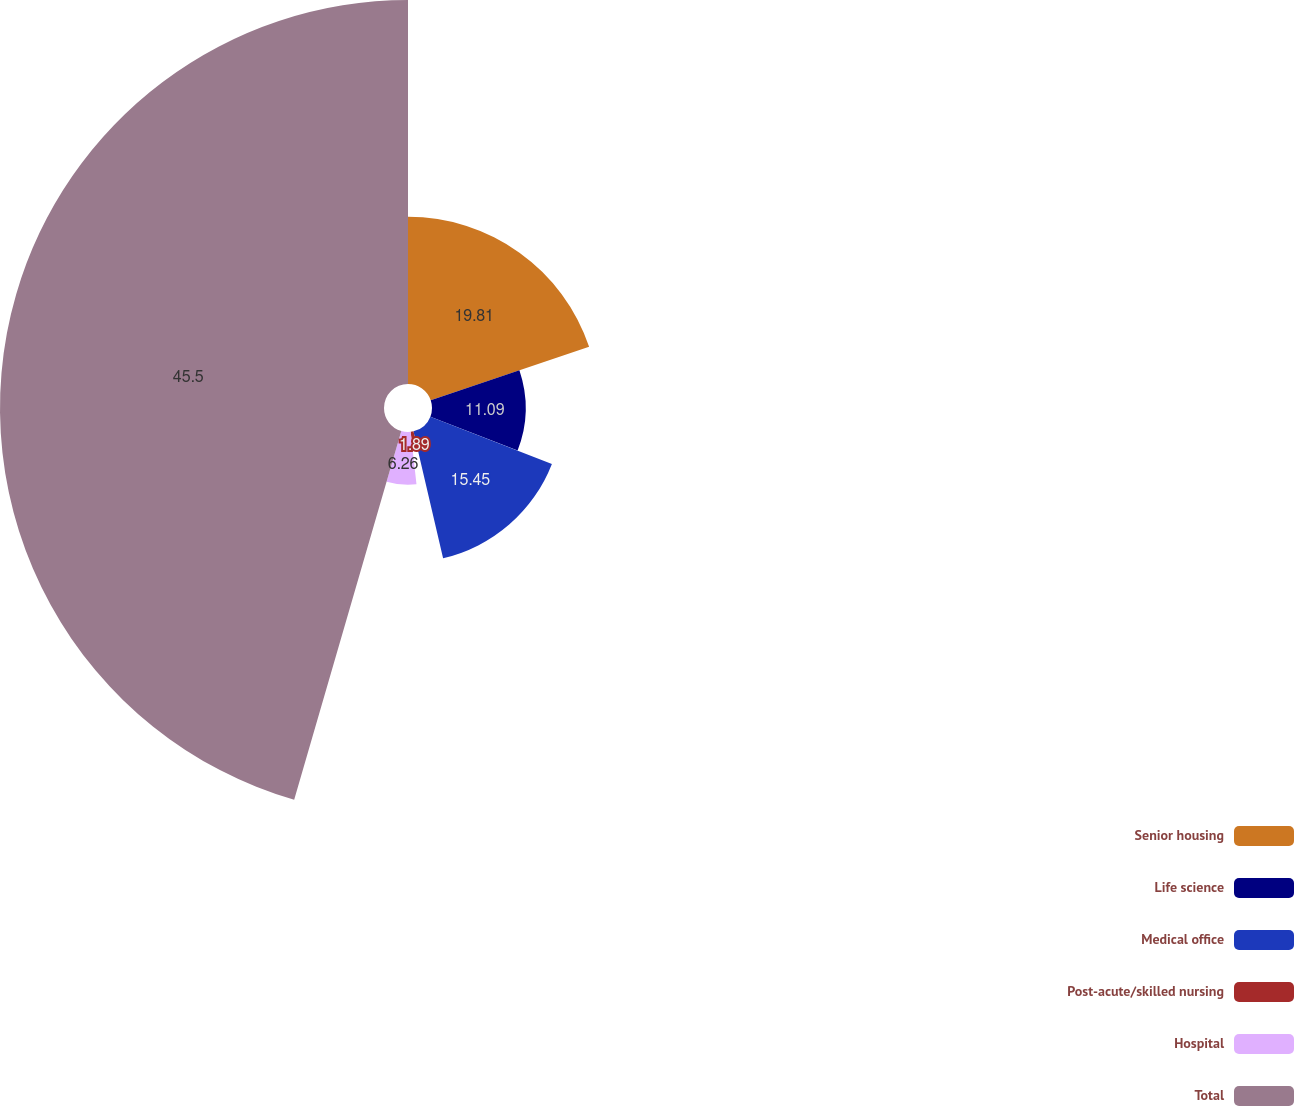Convert chart to OTSL. <chart><loc_0><loc_0><loc_500><loc_500><pie_chart><fcel>Senior housing<fcel>Life science<fcel>Medical office<fcel>Post-acute/skilled nursing<fcel>Hospital<fcel>Total<nl><fcel>19.81%<fcel>11.09%<fcel>15.45%<fcel>1.89%<fcel>6.26%<fcel>45.5%<nl></chart> 